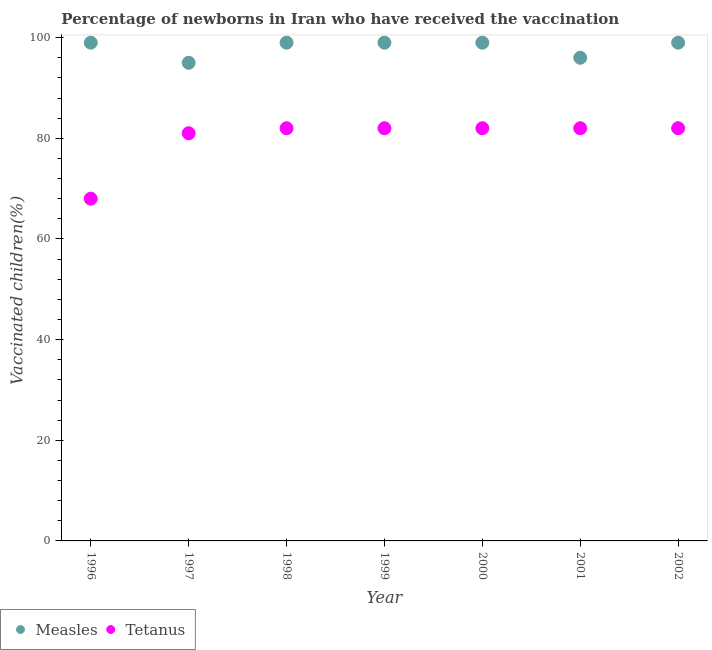What is the percentage of newborns who received vaccination for measles in 2002?
Your response must be concise. 99. Across all years, what is the maximum percentage of newborns who received vaccination for tetanus?
Give a very brief answer. 82. Across all years, what is the minimum percentage of newborns who received vaccination for tetanus?
Provide a succinct answer. 68. In which year was the percentage of newborns who received vaccination for measles maximum?
Your answer should be very brief. 1996. In which year was the percentage of newborns who received vaccination for tetanus minimum?
Provide a succinct answer. 1996. What is the total percentage of newborns who received vaccination for measles in the graph?
Offer a terse response. 686. What is the difference between the percentage of newborns who received vaccination for measles in 1997 and that in 1999?
Provide a succinct answer. -4. What is the difference between the percentage of newborns who received vaccination for measles in 1999 and the percentage of newborns who received vaccination for tetanus in 2000?
Provide a short and direct response. 17. In the year 2002, what is the difference between the percentage of newborns who received vaccination for tetanus and percentage of newborns who received vaccination for measles?
Your answer should be very brief. -17. Is the percentage of newborns who received vaccination for measles in 1998 less than that in 2000?
Provide a succinct answer. No. Is the difference between the percentage of newborns who received vaccination for tetanus in 1996 and 1999 greater than the difference between the percentage of newborns who received vaccination for measles in 1996 and 1999?
Your answer should be very brief. No. What is the difference between the highest and the second highest percentage of newborns who received vaccination for measles?
Ensure brevity in your answer.  0. What is the difference between the highest and the lowest percentage of newborns who received vaccination for tetanus?
Ensure brevity in your answer.  14. Is the sum of the percentage of newborns who received vaccination for tetanus in 1999 and 2000 greater than the maximum percentage of newborns who received vaccination for measles across all years?
Make the answer very short. Yes. Does the percentage of newborns who received vaccination for measles monotonically increase over the years?
Offer a very short reply. No. Is the percentage of newborns who received vaccination for tetanus strictly greater than the percentage of newborns who received vaccination for measles over the years?
Make the answer very short. No. Is the percentage of newborns who received vaccination for tetanus strictly less than the percentage of newborns who received vaccination for measles over the years?
Your response must be concise. Yes. How many dotlines are there?
Your answer should be compact. 2. How many years are there in the graph?
Give a very brief answer. 7. What is the difference between two consecutive major ticks on the Y-axis?
Ensure brevity in your answer.  20. Are the values on the major ticks of Y-axis written in scientific E-notation?
Provide a short and direct response. No. Does the graph contain any zero values?
Give a very brief answer. No. Does the graph contain grids?
Give a very brief answer. No. Where does the legend appear in the graph?
Make the answer very short. Bottom left. How are the legend labels stacked?
Ensure brevity in your answer.  Horizontal. What is the title of the graph?
Make the answer very short. Percentage of newborns in Iran who have received the vaccination. Does "Automatic Teller Machines" appear as one of the legend labels in the graph?
Give a very brief answer. No. What is the label or title of the X-axis?
Offer a terse response. Year. What is the label or title of the Y-axis?
Offer a terse response. Vaccinated children(%)
. What is the Vaccinated children(%)
 in Measles in 1996?
Give a very brief answer. 99. What is the Vaccinated children(%)
 of Tetanus in 1996?
Offer a terse response. 68. What is the Vaccinated children(%)
 in Measles in 1997?
Give a very brief answer. 95. What is the Vaccinated children(%)
 of Tetanus in 1997?
Provide a short and direct response. 81. What is the Vaccinated children(%)
 of Tetanus in 2000?
Ensure brevity in your answer.  82. What is the Vaccinated children(%)
 in Measles in 2001?
Give a very brief answer. 96. What is the Vaccinated children(%)
 in Tetanus in 2002?
Give a very brief answer. 82. Across all years, what is the minimum Vaccinated children(%)
 of Measles?
Give a very brief answer. 95. What is the total Vaccinated children(%)
 in Measles in the graph?
Keep it short and to the point. 686. What is the total Vaccinated children(%)
 of Tetanus in the graph?
Provide a succinct answer. 559. What is the difference between the Vaccinated children(%)
 of Tetanus in 1996 and that in 1997?
Give a very brief answer. -13. What is the difference between the Vaccinated children(%)
 in Measles in 1996 and that in 1998?
Offer a very short reply. 0. What is the difference between the Vaccinated children(%)
 in Tetanus in 1996 and that in 1998?
Your answer should be compact. -14. What is the difference between the Vaccinated children(%)
 of Measles in 1996 and that in 2000?
Make the answer very short. 0. What is the difference between the Vaccinated children(%)
 in Tetanus in 1997 and that in 1998?
Your response must be concise. -1. What is the difference between the Vaccinated children(%)
 in Measles in 1997 and that in 1999?
Your response must be concise. -4. What is the difference between the Vaccinated children(%)
 of Tetanus in 1997 and that in 1999?
Keep it short and to the point. -1. What is the difference between the Vaccinated children(%)
 of Measles in 1997 and that in 2000?
Offer a very short reply. -4. What is the difference between the Vaccinated children(%)
 in Tetanus in 1997 and that in 2000?
Provide a succinct answer. -1. What is the difference between the Vaccinated children(%)
 in Tetanus in 1997 and that in 2001?
Make the answer very short. -1. What is the difference between the Vaccinated children(%)
 of Tetanus in 1997 and that in 2002?
Give a very brief answer. -1. What is the difference between the Vaccinated children(%)
 of Measles in 1998 and that in 2000?
Provide a short and direct response. 0. What is the difference between the Vaccinated children(%)
 of Tetanus in 1999 and that in 2000?
Offer a terse response. 0. What is the difference between the Vaccinated children(%)
 in Measles in 1999 and that in 2001?
Keep it short and to the point. 3. What is the difference between the Vaccinated children(%)
 in Tetanus in 1999 and that in 2002?
Make the answer very short. 0. What is the difference between the Vaccinated children(%)
 of Tetanus in 2000 and that in 2001?
Your response must be concise. 0. What is the difference between the Vaccinated children(%)
 of Tetanus in 2000 and that in 2002?
Your response must be concise. 0. What is the difference between the Vaccinated children(%)
 of Measles in 2001 and that in 2002?
Offer a very short reply. -3. What is the difference between the Vaccinated children(%)
 in Measles in 1996 and the Vaccinated children(%)
 in Tetanus in 1998?
Your answer should be very brief. 17. What is the difference between the Vaccinated children(%)
 of Measles in 1996 and the Vaccinated children(%)
 of Tetanus in 1999?
Offer a very short reply. 17. What is the difference between the Vaccinated children(%)
 in Measles in 1997 and the Vaccinated children(%)
 in Tetanus in 2000?
Offer a terse response. 13. What is the difference between the Vaccinated children(%)
 in Measles in 1998 and the Vaccinated children(%)
 in Tetanus in 1999?
Make the answer very short. 17. What is the difference between the Vaccinated children(%)
 in Measles in 1998 and the Vaccinated children(%)
 in Tetanus in 2000?
Provide a succinct answer. 17. What is the difference between the Vaccinated children(%)
 in Measles in 1998 and the Vaccinated children(%)
 in Tetanus in 2001?
Offer a very short reply. 17. What is the difference between the Vaccinated children(%)
 of Measles in 1998 and the Vaccinated children(%)
 of Tetanus in 2002?
Your response must be concise. 17. What is the difference between the Vaccinated children(%)
 of Measles in 1999 and the Vaccinated children(%)
 of Tetanus in 2002?
Offer a very short reply. 17. What is the difference between the Vaccinated children(%)
 of Measles in 2000 and the Vaccinated children(%)
 of Tetanus in 2001?
Your answer should be compact. 17. What is the difference between the Vaccinated children(%)
 in Measles in 2000 and the Vaccinated children(%)
 in Tetanus in 2002?
Give a very brief answer. 17. What is the average Vaccinated children(%)
 of Measles per year?
Make the answer very short. 98. What is the average Vaccinated children(%)
 in Tetanus per year?
Give a very brief answer. 79.86. In the year 1996, what is the difference between the Vaccinated children(%)
 of Measles and Vaccinated children(%)
 of Tetanus?
Make the answer very short. 31. In the year 1999, what is the difference between the Vaccinated children(%)
 in Measles and Vaccinated children(%)
 in Tetanus?
Provide a succinct answer. 17. In the year 2000, what is the difference between the Vaccinated children(%)
 in Measles and Vaccinated children(%)
 in Tetanus?
Your answer should be very brief. 17. In the year 2001, what is the difference between the Vaccinated children(%)
 of Measles and Vaccinated children(%)
 of Tetanus?
Offer a terse response. 14. In the year 2002, what is the difference between the Vaccinated children(%)
 in Measles and Vaccinated children(%)
 in Tetanus?
Your answer should be very brief. 17. What is the ratio of the Vaccinated children(%)
 in Measles in 1996 to that in 1997?
Provide a succinct answer. 1.04. What is the ratio of the Vaccinated children(%)
 in Tetanus in 1996 to that in 1997?
Ensure brevity in your answer.  0.84. What is the ratio of the Vaccinated children(%)
 in Measles in 1996 to that in 1998?
Provide a succinct answer. 1. What is the ratio of the Vaccinated children(%)
 in Tetanus in 1996 to that in 1998?
Your response must be concise. 0.83. What is the ratio of the Vaccinated children(%)
 in Tetanus in 1996 to that in 1999?
Your response must be concise. 0.83. What is the ratio of the Vaccinated children(%)
 in Measles in 1996 to that in 2000?
Offer a terse response. 1. What is the ratio of the Vaccinated children(%)
 in Tetanus in 1996 to that in 2000?
Your answer should be very brief. 0.83. What is the ratio of the Vaccinated children(%)
 of Measles in 1996 to that in 2001?
Give a very brief answer. 1.03. What is the ratio of the Vaccinated children(%)
 of Tetanus in 1996 to that in 2001?
Make the answer very short. 0.83. What is the ratio of the Vaccinated children(%)
 of Measles in 1996 to that in 2002?
Offer a terse response. 1. What is the ratio of the Vaccinated children(%)
 in Tetanus in 1996 to that in 2002?
Your response must be concise. 0.83. What is the ratio of the Vaccinated children(%)
 of Measles in 1997 to that in 1998?
Your response must be concise. 0.96. What is the ratio of the Vaccinated children(%)
 in Tetanus in 1997 to that in 1998?
Your response must be concise. 0.99. What is the ratio of the Vaccinated children(%)
 in Measles in 1997 to that in 1999?
Provide a succinct answer. 0.96. What is the ratio of the Vaccinated children(%)
 in Measles in 1997 to that in 2000?
Provide a succinct answer. 0.96. What is the ratio of the Vaccinated children(%)
 of Tetanus in 1997 to that in 2000?
Keep it short and to the point. 0.99. What is the ratio of the Vaccinated children(%)
 in Measles in 1997 to that in 2001?
Your answer should be compact. 0.99. What is the ratio of the Vaccinated children(%)
 of Tetanus in 1997 to that in 2001?
Ensure brevity in your answer.  0.99. What is the ratio of the Vaccinated children(%)
 of Measles in 1997 to that in 2002?
Your answer should be compact. 0.96. What is the ratio of the Vaccinated children(%)
 in Tetanus in 1997 to that in 2002?
Offer a very short reply. 0.99. What is the ratio of the Vaccinated children(%)
 in Measles in 1998 to that in 1999?
Your answer should be very brief. 1. What is the ratio of the Vaccinated children(%)
 of Tetanus in 1998 to that in 1999?
Keep it short and to the point. 1. What is the ratio of the Vaccinated children(%)
 of Measles in 1998 to that in 2000?
Provide a short and direct response. 1. What is the ratio of the Vaccinated children(%)
 in Tetanus in 1998 to that in 2000?
Provide a short and direct response. 1. What is the ratio of the Vaccinated children(%)
 of Measles in 1998 to that in 2001?
Provide a succinct answer. 1.03. What is the ratio of the Vaccinated children(%)
 of Tetanus in 1998 to that in 2001?
Give a very brief answer. 1. What is the ratio of the Vaccinated children(%)
 of Measles in 1999 to that in 2000?
Your answer should be compact. 1. What is the ratio of the Vaccinated children(%)
 in Measles in 1999 to that in 2001?
Give a very brief answer. 1.03. What is the ratio of the Vaccinated children(%)
 in Measles in 2000 to that in 2001?
Make the answer very short. 1.03. What is the ratio of the Vaccinated children(%)
 of Measles in 2000 to that in 2002?
Give a very brief answer. 1. What is the ratio of the Vaccinated children(%)
 of Measles in 2001 to that in 2002?
Ensure brevity in your answer.  0.97. What is the difference between the highest and the lowest Vaccinated children(%)
 in Tetanus?
Give a very brief answer. 14. 